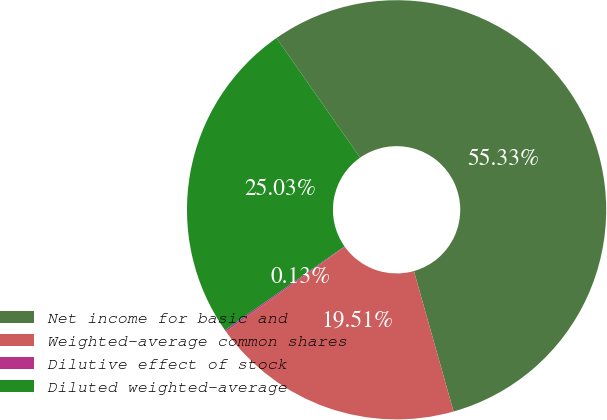<chart> <loc_0><loc_0><loc_500><loc_500><pie_chart><fcel>Net income for basic and<fcel>Weighted-average common shares<fcel>Dilutive effect of stock<fcel>Diluted weighted-average<nl><fcel>55.33%<fcel>19.51%<fcel>0.13%<fcel>25.03%<nl></chart> 